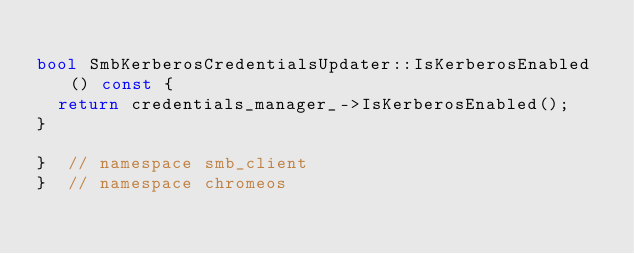<code> <loc_0><loc_0><loc_500><loc_500><_C++_>
bool SmbKerberosCredentialsUpdater::IsKerberosEnabled() const {
  return credentials_manager_->IsKerberosEnabled();
}

}  // namespace smb_client
}  // namespace chromeos
</code> 